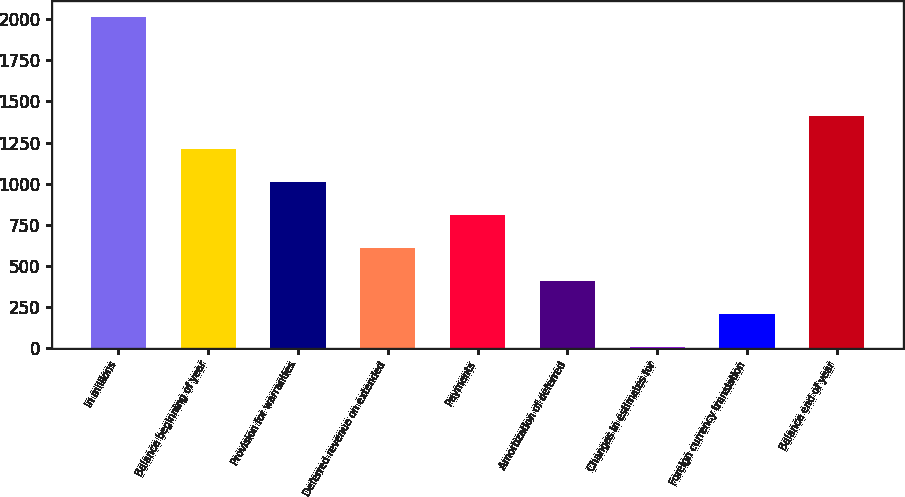Convert chart to OTSL. <chart><loc_0><loc_0><loc_500><loc_500><bar_chart><fcel>In millions<fcel>Balance beginning of year<fcel>Provision for warranties<fcel>Deferred revenue on extended<fcel>Payments<fcel>Amortization of deferred<fcel>Changes in estimates for<fcel>Foreign currency translation<fcel>Balance end of year<nl><fcel>2011<fcel>1209.4<fcel>1009<fcel>608.2<fcel>808.6<fcel>407.8<fcel>7<fcel>207.4<fcel>1409.8<nl></chart> 